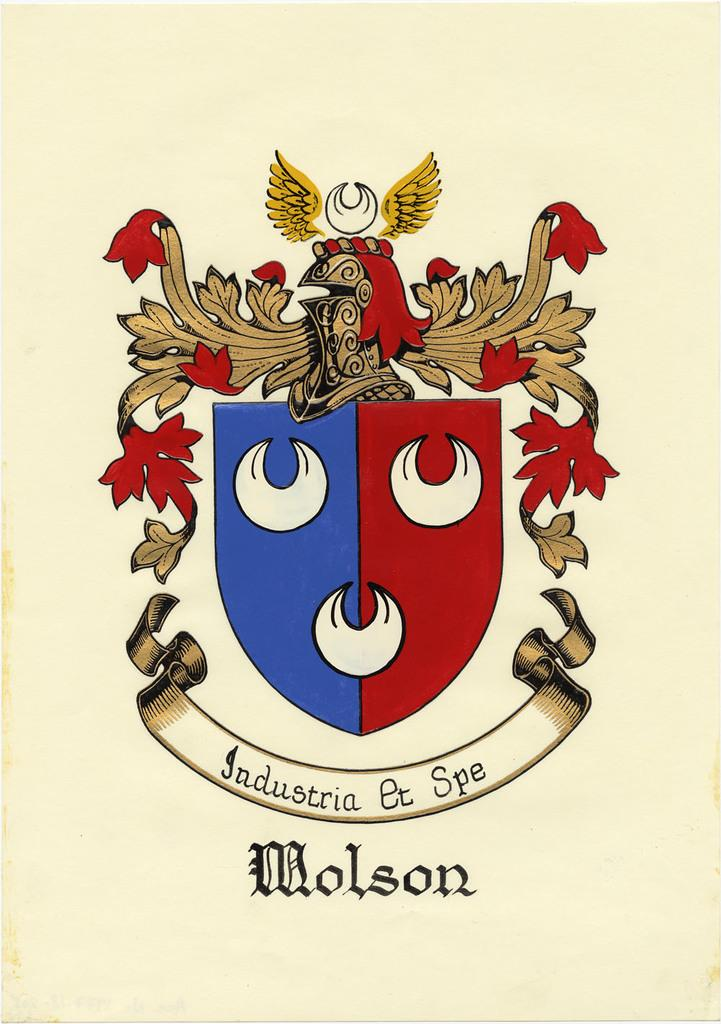What is present on the poster in the image? There is a poster in the image. What type of images are featured on the poster? The poster contains cartoon images. What else can be seen on the poster besides the images? There is text on the poster. What type of crack can be seen on the poster in the image? There is no crack present on the poster in the image. What is the poster used for in the image? The poster's purpose cannot be determined from the image alone, as it only shows the poster with cartoon images and text. 